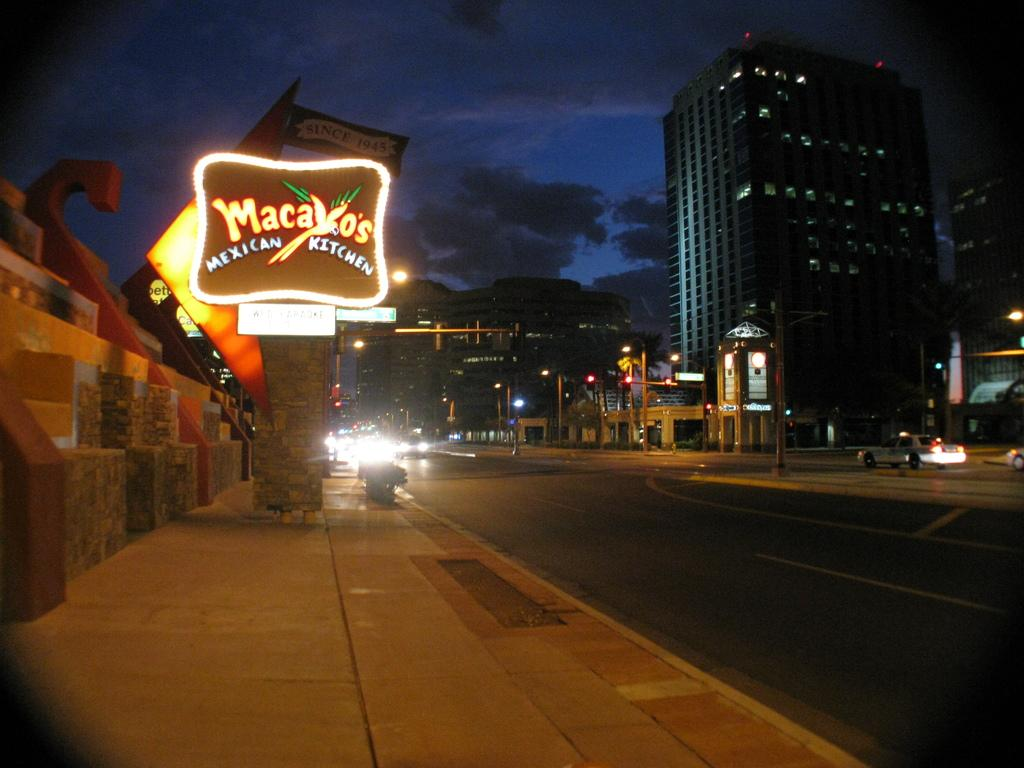What type of pathway is present in the image? There is a road in the image. What is the purpose of the adjacent pathway? There is a sidewalk in the image. What can be seen traveling on the road? There are vehicles on the road. What objects are present in the image that might be used for displaying information or advertisements? There are boards in the image. What objects in the image might provide illumination? There are lights in the image. What objects in the image might support the lights or other structures? There are poles in the image. What structures are visible in the background of the image? There are buildings in the image. What part of the natural environment is visible in the background of the image? The sky is visible in the background of the image. What type of scent can be detected coming from the buildings in the image? There is no information about scents in the image, as it focuses on visual elements such as pathways, vehicles, and structures. 